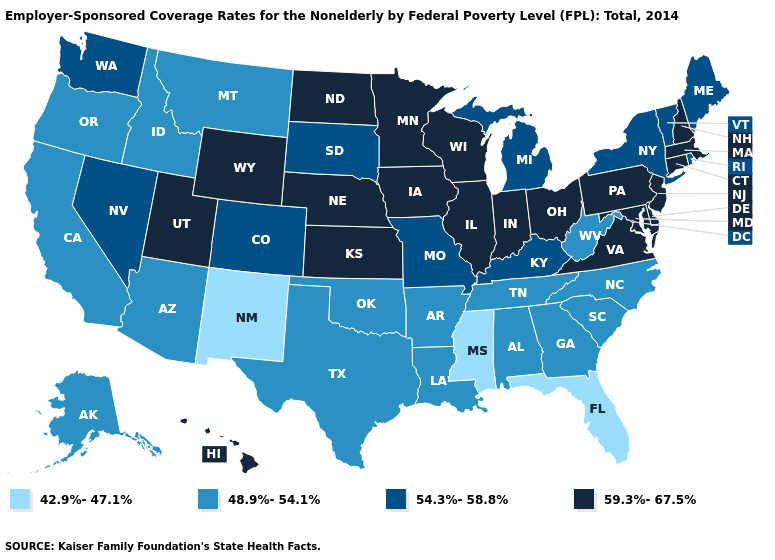Among the states that border Michigan , which have the highest value?
Short answer required. Indiana, Ohio, Wisconsin. What is the lowest value in the USA?
Write a very short answer. 42.9%-47.1%. Which states have the lowest value in the West?
Short answer required. New Mexico. Which states hav the highest value in the Northeast?
Keep it brief. Connecticut, Massachusetts, New Hampshire, New Jersey, Pennsylvania. What is the value of Oklahoma?
Write a very short answer. 48.9%-54.1%. Does New Hampshire have the same value as Texas?
Short answer required. No. Among the states that border New Mexico , does Utah have the highest value?
Concise answer only. Yes. What is the highest value in the West ?
Answer briefly. 59.3%-67.5%. What is the value of Nebraska?
Quick response, please. 59.3%-67.5%. Name the states that have a value in the range 48.9%-54.1%?
Short answer required. Alabama, Alaska, Arizona, Arkansas, California, Georgia, Idaho, Louisiana, Montana, North Carolina, Oklahoma, Oregon, South Carolina, Tennessee, Texas, West Virginia. What is the lowest value in states that border Illinois?
Give a very brief answer. 54.3%-58.8%. Which states have the lowest value in the West?
Be succinct. New Mexico. Does the map have missing data?
Short answer required. No. What is the lowest value in the West?
Short answer required. 42.9%-47.1%. Does Louisiana have a lower value than North Carolina?
Short answer required. No. 